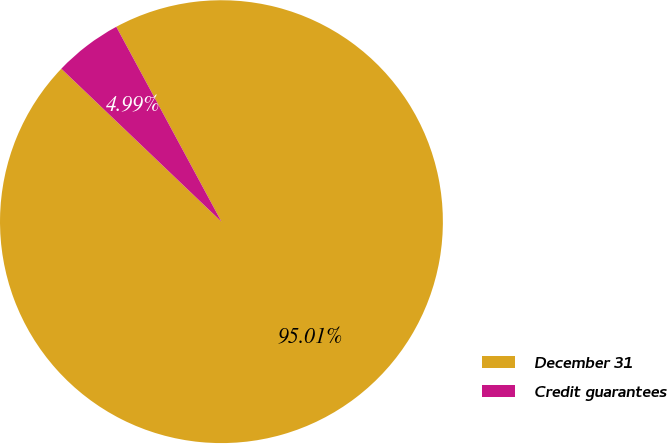Convert chart. <chart><loc_0><loc_0><loc_500><loc_500><pie_chart><fcel>December 31<fcel>Credit guarantees<nl><fcel>95.01%<fcel>4.99%<nl></chart> 